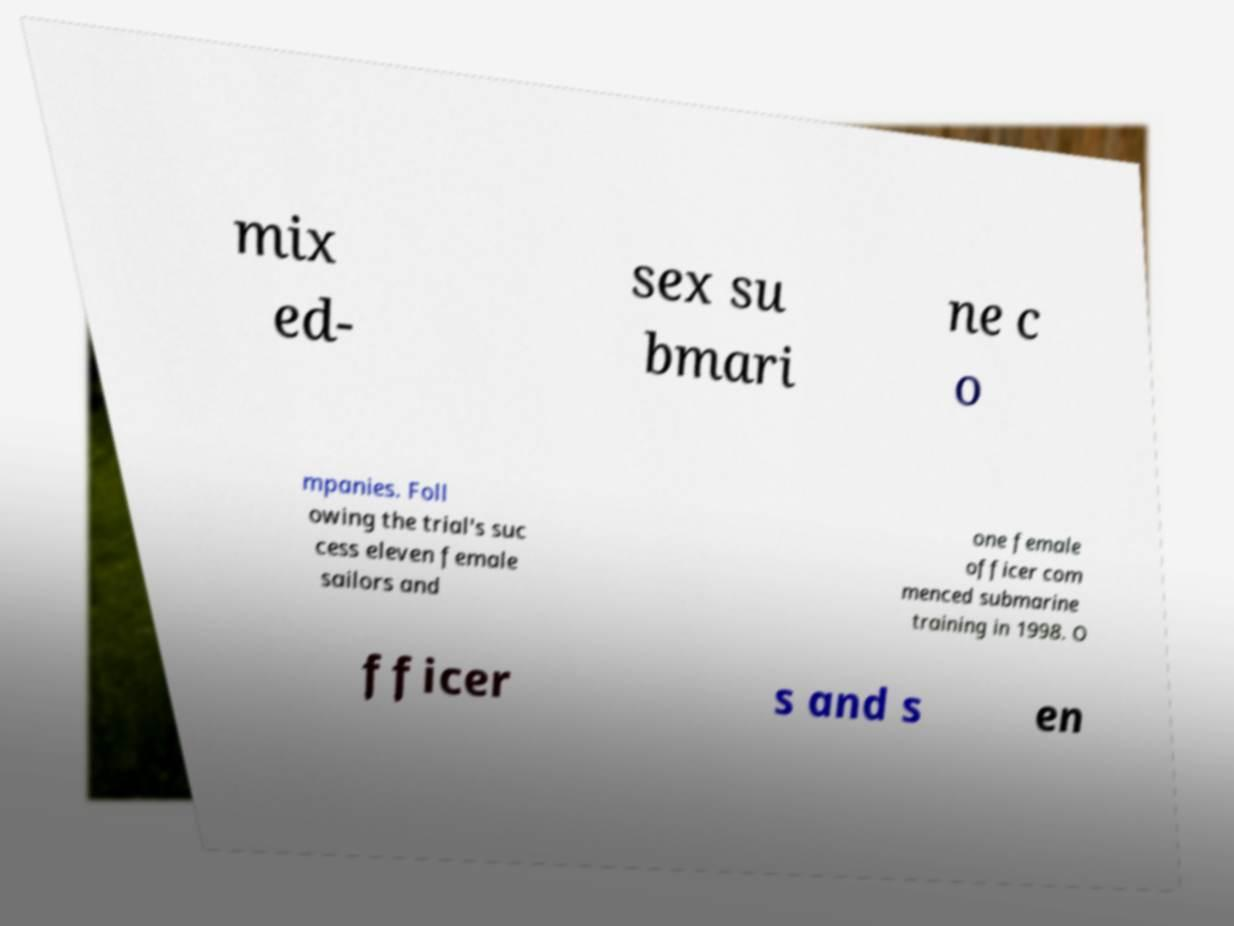Could you assist in decoding the text presented in this image and type it out clearly? mix ed- sex su bmari ne c o mpanies. Foll owing the trial's suc cess eleven female sailors and one female officer com menced submarine training in 1998. O fficer s and s en 